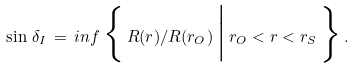<formula> <loc_0><loc_0><loc_500><loc_500>\sin \, \delta _ { I } \, = \, { i n f } \, \Big \{ \, R ( r ) / R ( r _ { O } ) \, \Big | \, r _ { O } < r < r _ { S } \, \Big \} \, .</formula> 